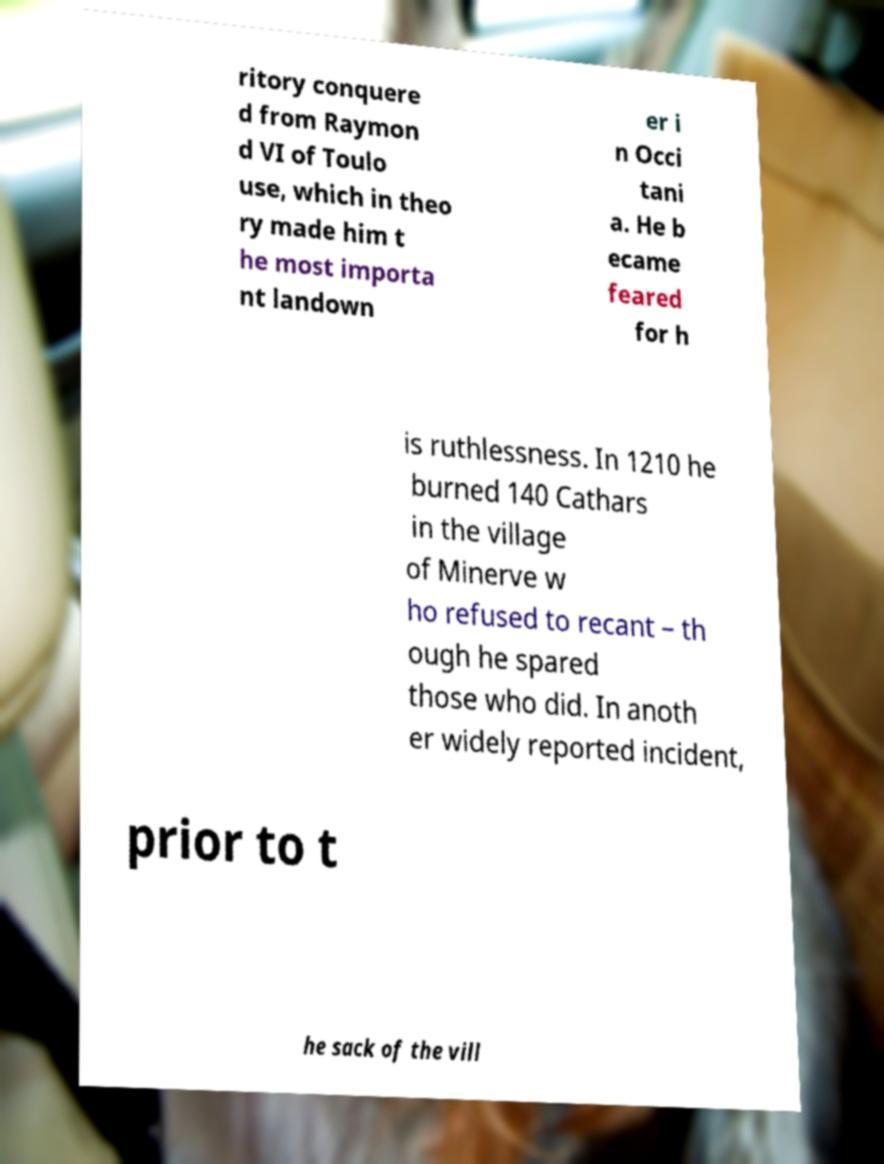Please read and relay the text visible in this image. What does it say? ritory conquere d from Raymon d VI of Toulo use, which in theo ry made him t he most importa nt landown er i n Occi tani a. He b ecame feared for h is ruthlessness. In 1210 he burned 140 Cathars in the village of Minerve w ho refused to recant – th ough he spared those who did. In anoth er widely reported incident, prior to t he sack of the vill 